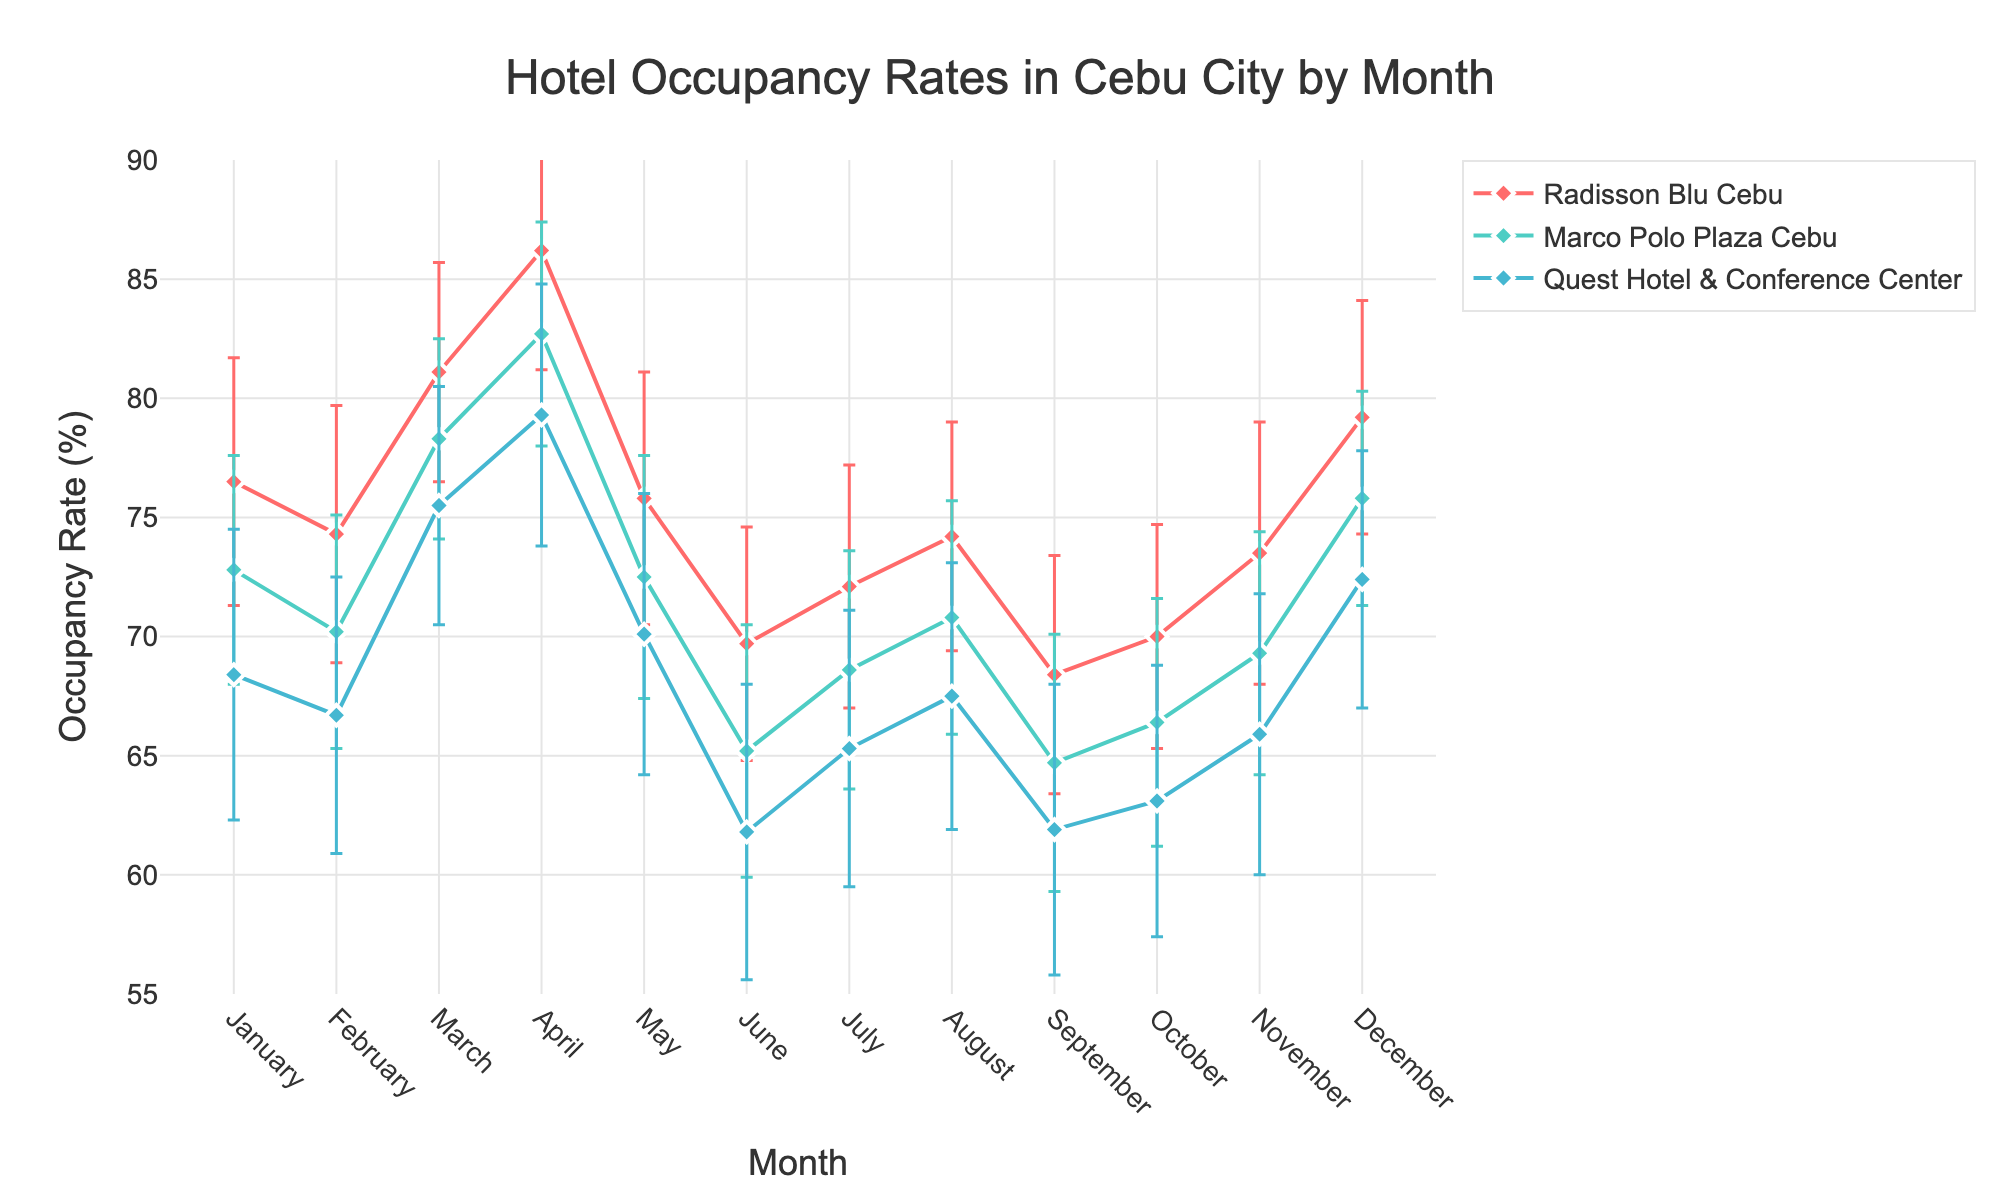What is the title of the plot? The title of the plot is typically displayed prominently at the top of the chart. It provides a brief description of what the plot represents. In this case, the title should be "Hotel Occupancy Rates in Cebu City by Month".
Answer: Hotel Occupancy Rates in Cebu City by Month Which hotel has the highest occupancy rate in April? By looking at the lines and markers in the plot, I can identify which hotel reaches the highest point in April. The Radisson Blu Cebu reaches an occupancy rate of 86.2% in April, which is higher compared to the other hotels.
Answer: Radisson Blu Cebu What’s the standard deviation of occupancy rates for Quest Hotel & Conference Center in January? The error bars represent the standard deviation. For Quest Hotel & Conference Center in January, the line and marker for this hotel will show an error bar with a ± value, which is labeled as 6.1%.
Answer: 6.1% In which month does Marco Polo Plaza Cebu show the lowest occupancy rate and what is the value? By examining the plot, the lowest point of the line representing Marco Polo Plaza Cebu indicates the lowest occupancy rate. This occurs in June, with an occupancy rate of 65.2%.
Answer: June, 65.2% How does the occupancy rate of Radisson Blu Cebu in May compare to its rate in March? To compare the two rates, I need to find the corresponding values for Radisson Blu Cebu in both months. In March, Radisson Blu Cebu has an occupancy rate of 81.1%, while in May, it drops to 75.8%.
Answer: It decreases from 81.1% to 75.8% Which month shows the biggest occupancy rate difference between Radisson Blu Cebu and Quest Hotel & Conference Center, and what is the difference? I need to inspect the plot to determine the largest gap between Radisson Blu Cebu and Quest Hotel & Conference Center in any month. The greatest difference appears in April, where Radisson Blu Cebu has 86.2% and Quest Hotel & Conference Center has 79.3%. The difference is 86.2% - 79.3% = 6.9%.
Answer: April, 6.9% What is the average occupancy rate of Marco Polo Plaza Cebu for the months January to March? To find the average, I first add the occupancy rates of January (72.8), February (70.2), and March (78.3) for Marco Polo Plaza Cebu. The sum is 72.8 + 70.2 + 78.3 = 221.3. I then divide by 3, the number of months. 221.3 / 3 ≈ 73.77%.
Answer: 73.8% Does Quest Hotel & Conference Center ever achieve an occupancy rate above 75%? By scanning the plot for the Quest Hotel & Conference Center line, I see that it reaches an occupancy rate of 75.5% in March and 79.3% in April. Thus, it exceeds 75% in these months.
Answer: Yes What can be inferred about the trend of hotel occupancy rates for Radisson Blu Cebu from January to December? Examining the plot, I observe that the occupancy rate for Radisson Blu Cebu shows a peak in April, dips in the middle of the year, and then rises again towards December. This suggests a fluctuating trend with high rates at the beginning and end of the year.
Answer: Fluctuating with peaks in April and December How does the variability in occupancy rates (standard deviation) for Marco Polo Plaza Cebu compare from January to June? I need to look at the error bars for Marco Polo Plaza Cebu from January to June. The lengths of the error bars represent the variability. Generally, the standard deviations (error bars) are quite similar but tend to be larger in the summer months (June).
Answer: Generally consistent, slightly increasing towards June 